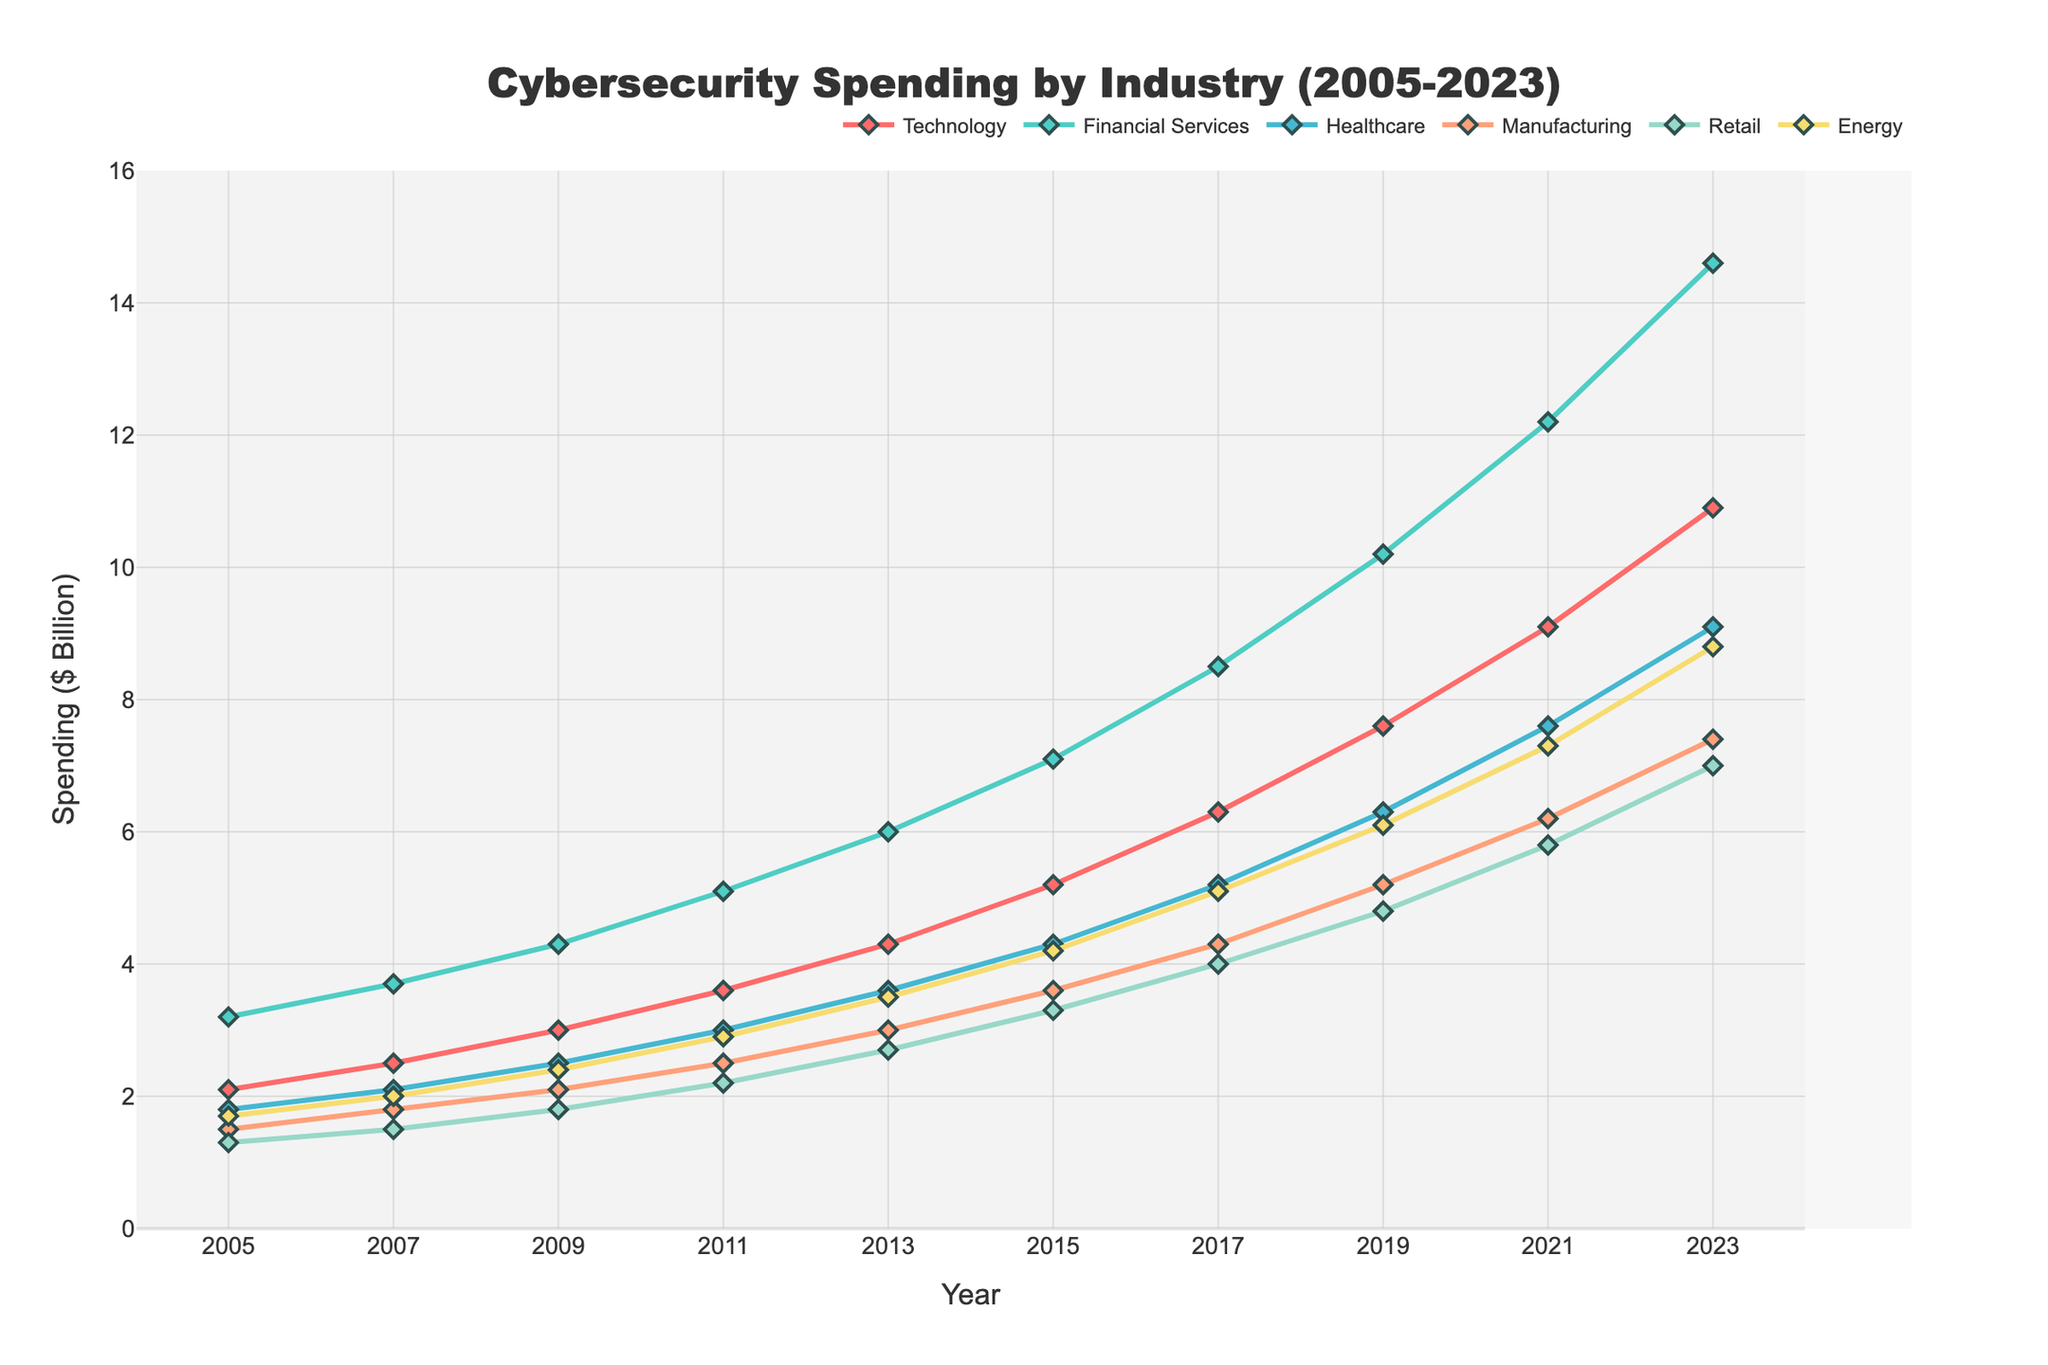How does the cybersecurity spending in Technology in 2023 compare to that in 2005? To find the difference, look at the 2023 spending for Technology, which is 10.9, and subtract the 2005 spending, which is 2.1. The difference is 10.9 - 2.1.
Answer: 8.8 Which industry had the highest cybersecurity spending in 2015, and how much was it? To identify the highest spend in 2015, look at the tallest marker in the year 2015. The Financial Services sector has the highest spending with a value of 7.1.
Answer: Financial Services, 7.1 Between 2017 to 2023, which industry saw the largest increase in cybersecurity spending? For each industry, subtract the 2017 value from the 2023 value. The differences are: Technology: 10.9-6.3=4.6, Financial Services: 14.6-8.5=6.1, Healthcare: 9.1-5.2=3.9, Manufacturing: 7.4-4.3=3.1, Retail: 7.0-4.0=3.0, Energy: 8.8-5.1=3.7. Financial Services has the largest increase of 6.1.
Answer: Financial Services, 6.1 What is the trend of cybersecurity spending in the Energy sector from 2005 to 2023? Observing the plot, the spending in the Energy sector increased steadily from 1.7 in 2005 to 8.8 in 2023.
Answer: Steadily Increasing Which two industries had the closest cybersecurity spending in 2007, and what were their values? Locate the points for 2007 and check for the closest values. Technology and Manufacturing both have very close values of around 2.5 and 2.0, respective differences being 0.5.
Answer: Technology (2.5), Manufacturing (2.0) How much more did the Financial Services industry spend on cybersecurity than the Healthcare industry in 2021? Subtract the 2021 value of Healthcare (7.6) from Financial Services (12.2). The difference is 12.2 - 7.6.
Answer: 4.6 What's the average cybersecurity spending for the Retail industry from 2005 to 2023? Sum all the annual spending values for Retail (1.3 + 1.5 + ... + 7.0) and divide by the number of years (10). Total = 40.1, so the average is 40.1/10 = 4.01.
Answer: 4.01 In which year did the Technology and Retail industries both experience the same rate of increase in spending from the previous period? Compare each year's increment. Between 2009 and 2011, both Technology (3.6-3.0=0.6) and Retail (2.2-1.8=0.4), another close match is 2017 to 2019: Tech (7.6-6.3)=1.3, Retail (4.8-4.0)=0.8.
Answer: Between 2007 to 2009 or 2017 to 2019 What color is used to represent the Healthcare industry, and how does the spending trend look from 2005 to 2023 for this sector? The Healthcare industry line is shown in purple (as an example). The trend shows a consistent increase from 1.8 in 2005 to 9.1 in 2023.
Answer: Purple, consistently increasing During which periods did the Manufacturing sector see the highest growth in cybersecurity spending? Identify the steepest slopes in the Manufacturing line. The most significant slope changes appear between 2011-2013 (from 3.0 to 3.6) and 2017-2019 (from 4.3 to 5.2) showing higher growths.
Answer: 2011-2013 and 2017-2019 